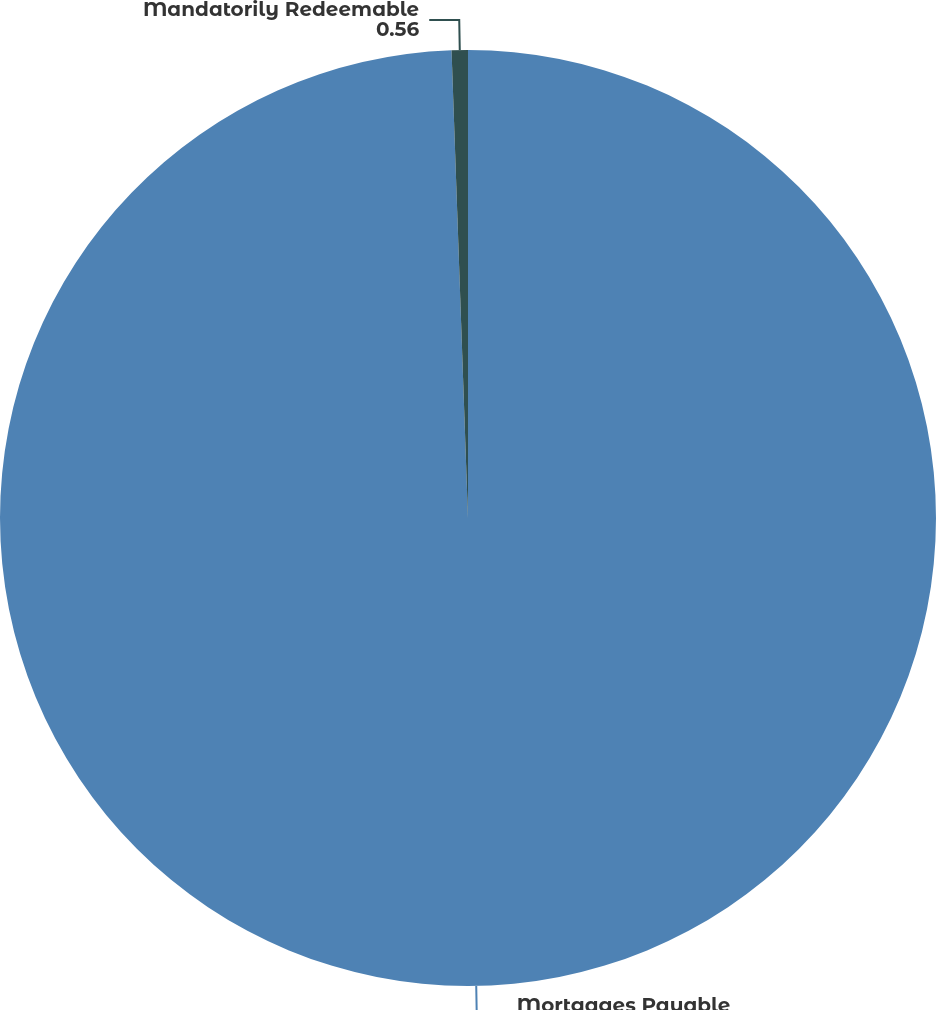<chart> <loc_0><loc_0><loc_500><loc_500><pie_chart><fcel>Mortgages Payable<fcel>Mandatorily Redeemable<nl><fcel>99.44%<fcel>0.56%<nl></chart> 